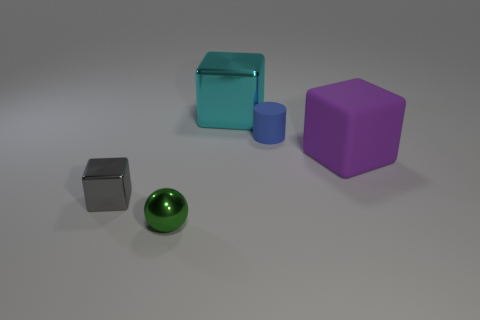Add 5 small blue things. How many objects exist? 10 Subtract all cyan blocks. How many blocks are left? 2 Subtract all tiny gray blocks. How many blocks are left? 2 Subtract all cubes. How many objects are left? 2 Subtract all yellow blocks. Subtract all gray cylinders. How many blocks are left? 3 Subtract all red balls. How many cyan cubes are left? 1 Subtract all small gray things. Subtract all cyan blocks. How many objects are left? 3 Add 3 small metallic objects. How many small metallic objects are left? 5 Add 1 brown metallic spheres. How many brown metallic spheres exist? 1 Subtract 0 red blocks. How many objects are left? 5 